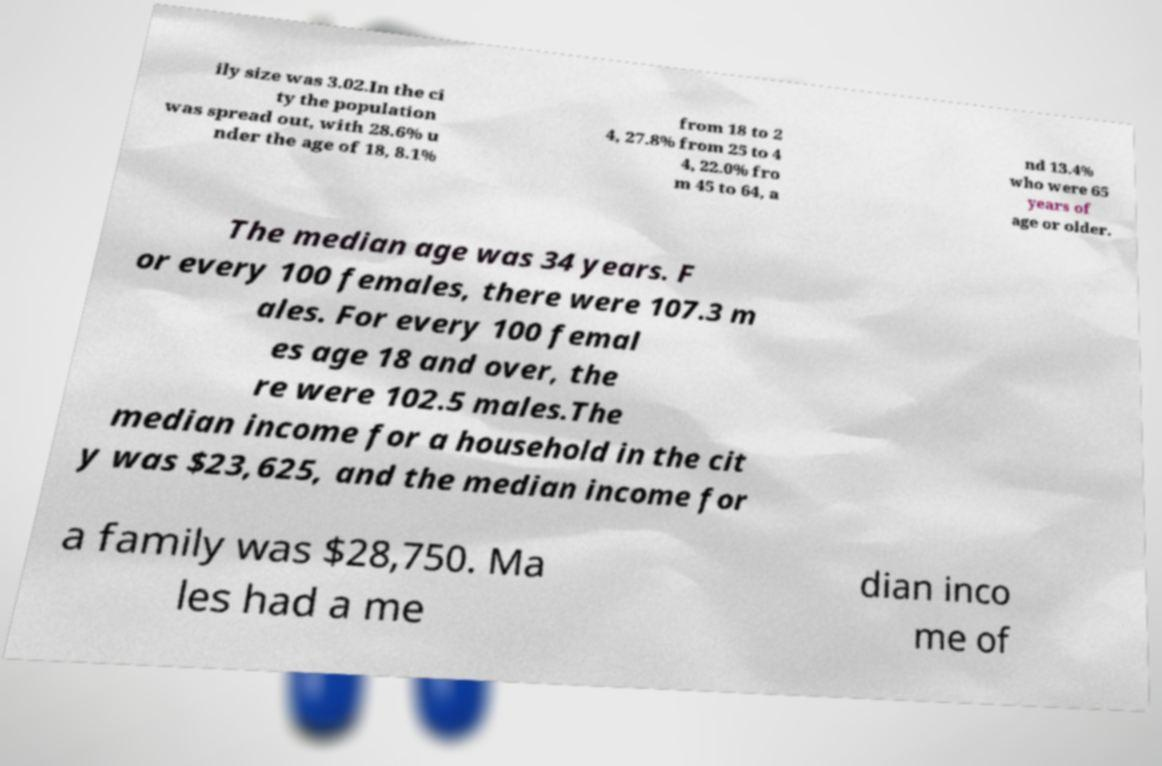Could you assist in decoding the text presented in this image and type it out clearly? ily size was 3.02.In the ci ty the population was spread out, with 28.6% u nder the age of 18, 8.1% from 18 to 2 4, 27.8% from 25 to 4 4, 22.0% fro m 45 to 64, a nd 13.4% who were 65 years of age or older. The median age was 34 years. F or every 100 females, there were 107.3 m ales. For every 100 femal es age 18 and over, the re were 102.5 males.The median income for a household in the cit y was $23,625, and the median income for a family was $28,750. Ma les had a me dian inco me of 